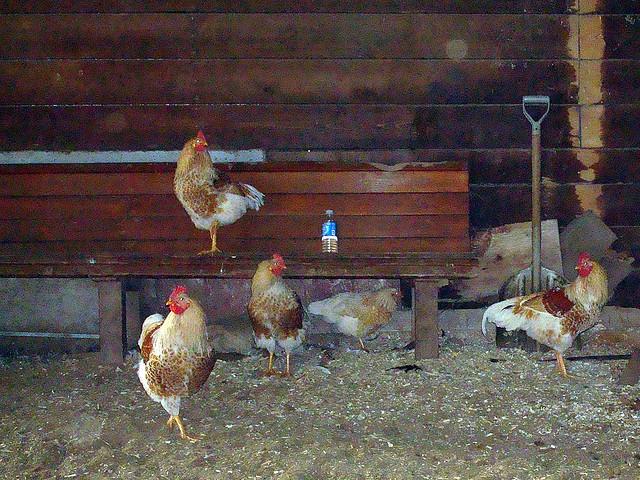What is on the bench with the chicken?
Quick response, please. Water bottle. How many chickens are there with redheads?
Quick response, please. 4. Are these roosters?
Keep it brief. Yes. 